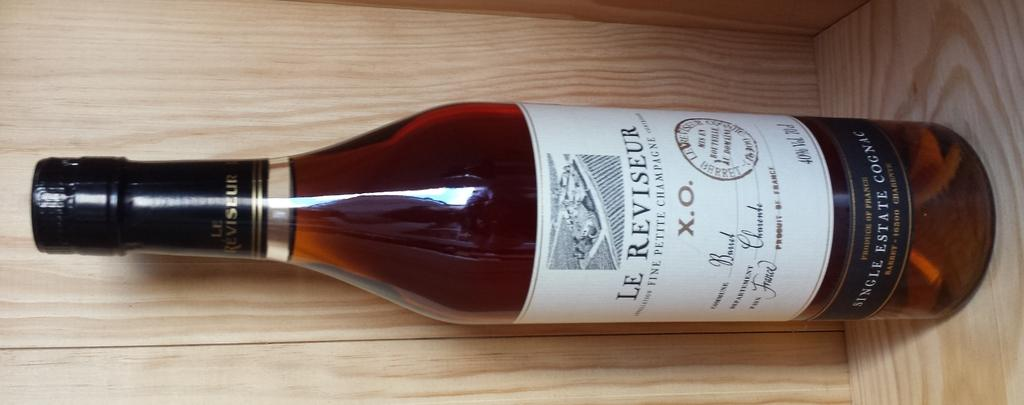<image>
Write a terse but informative summary of the picture. A bottle of Le Reviseur sits in a wooden crate. 